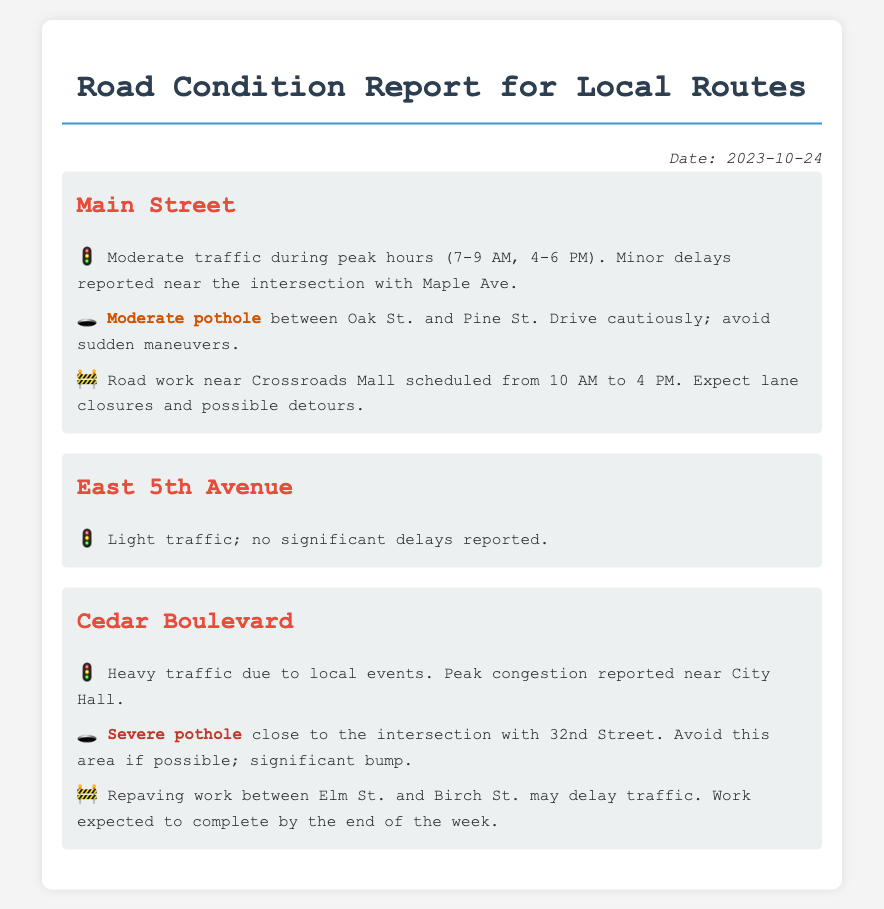What is the date of the report? The date is clearly stated at the top of the document.
Answer: 2023-10-24 Which route has moderate traffic during peak hours? The traffic section specifies the route with moderate traffic during certain times.
Answer: Main Street What type of pothole is reported on Cedar Boulevard? The pothole section describes the severity of potholes for each route.
Answer: Severe pothole What construction is scheduled on Main Street? The construction section outlines the location and timing of road work.
Answer: Road work near Crossroads Mall What is reported near City Hall? The traffic observation notes congestion related to local events.
Answer: Heavy traffic 